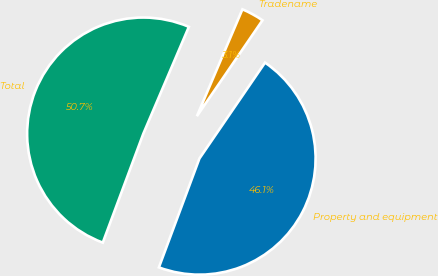<chart> <loc_0><loc_0><loc_500><loc_500><pie_chart><fcel>Property and equipment<fcel>Tradename<fcel>Total<nl><fcel>46.12%<fcel>3.14%<fcel>50.74%<nl></chart> 